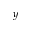Convert formula to latex. <formula><loc_0><loc_0><loc_500><loc_500>y</formula> 